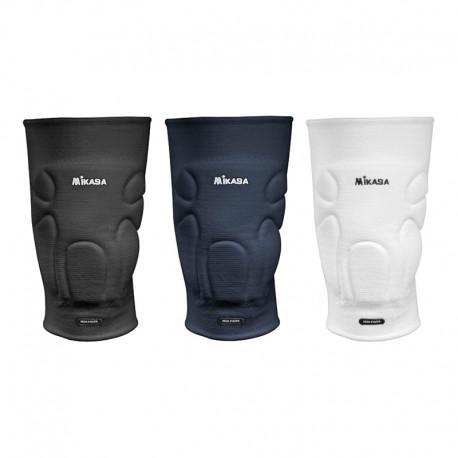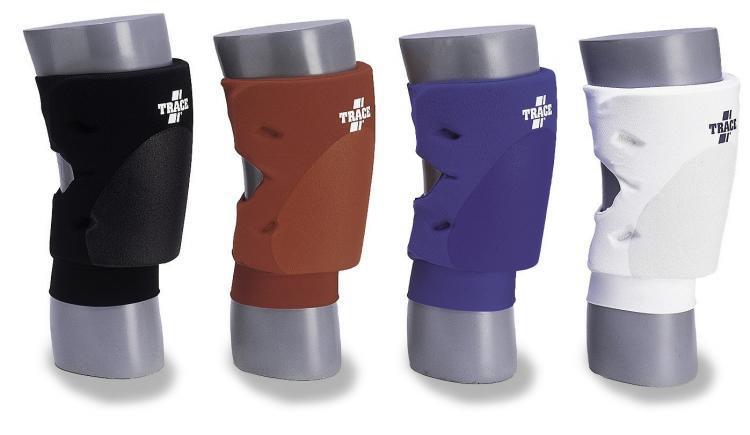The first image is the image on the left, the second image is the image on the right. For the images displayed, is the sentence "There are exactly seven knee pads in total." factually correct? Answer yes or no. Yes. The first image is the image on the left, the second image is the image on the right. Examine the images to the left and right. Is the description "There are exactly seven knee braces in total." accurate? Answer yes or no. Yes. 